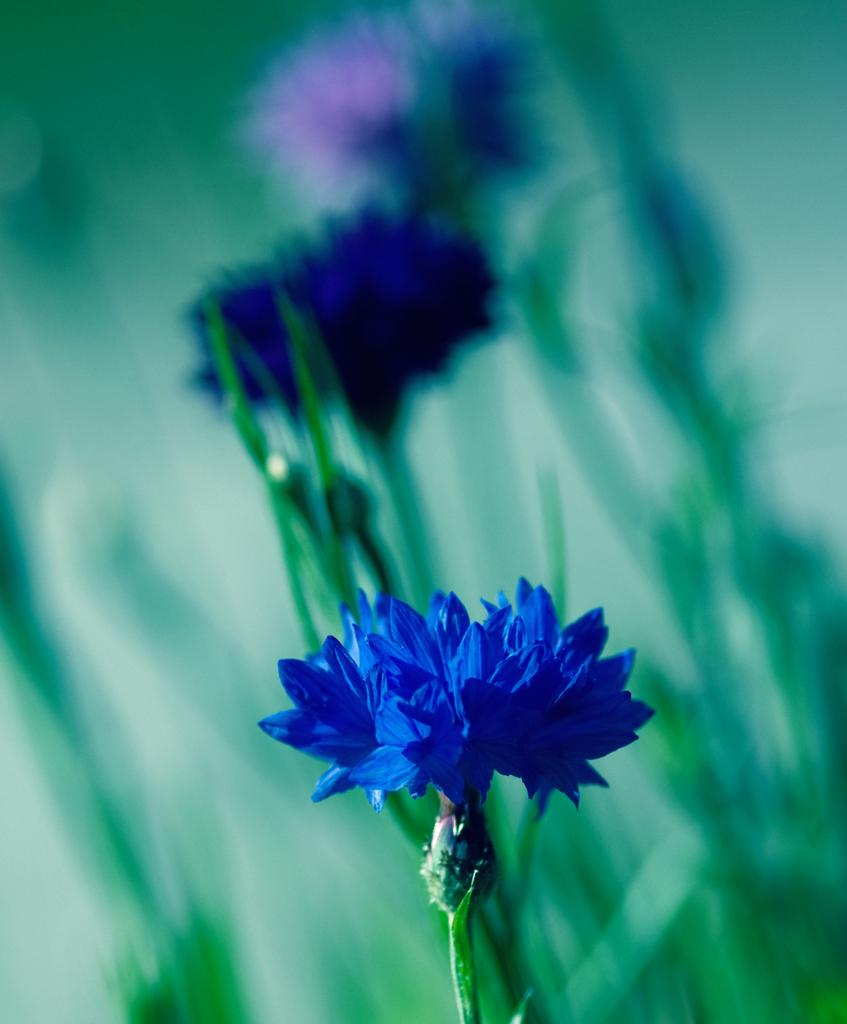What type of living organisms can be seen in the image? There are flowers in the image. What color are the objects in the image? There are green color objects in the image. What type of appliance can be seen in the image? There is no appliance present in the image. 